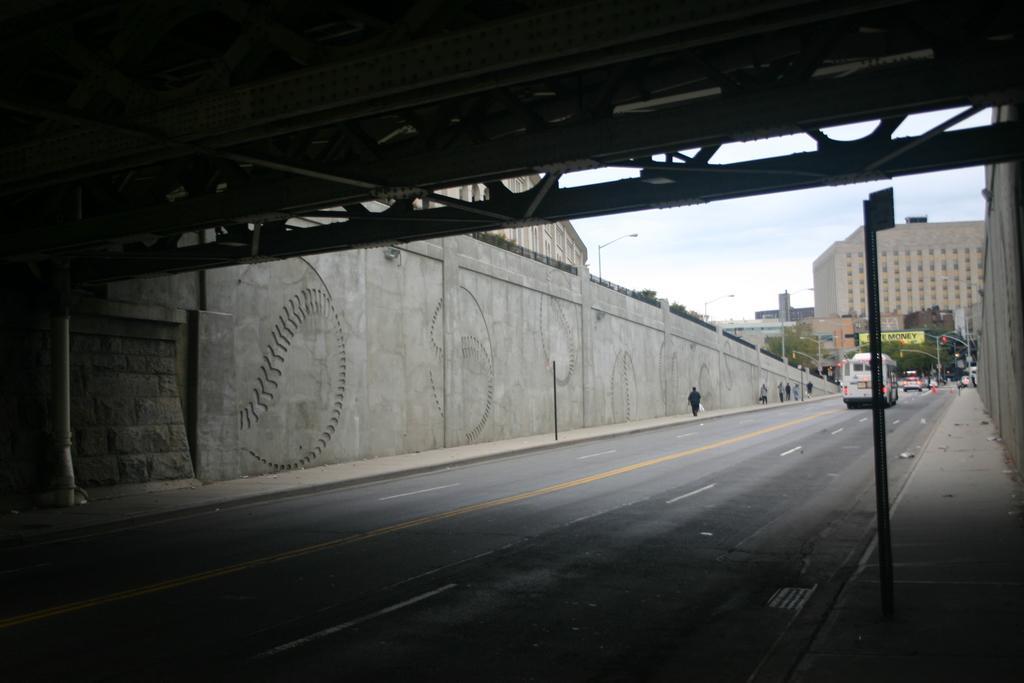Please provide a concise description of this image. In the image there are few vehicles going in the front on the road, this is clicked from under a bridge, in the back there are buildings with trees in front of it and above its sky. 